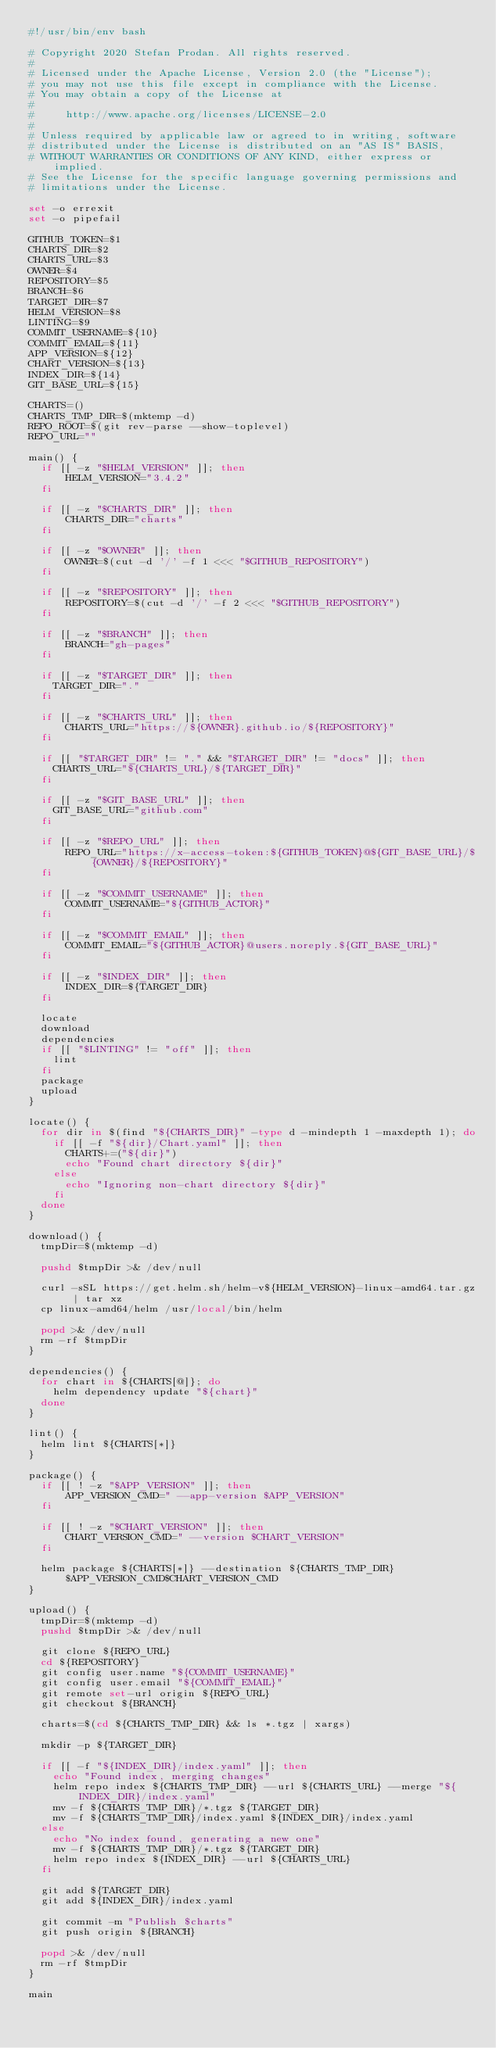<code> <loc_0><loc_0><loc_500><loc_500><_Bash_>#!/usr/bin/env bash

# Copyright 2020 Stefan Prodan. All rights reserved.
#
# Licensed under the Apache License, Version 2.0 (the "License");
# you may not use this file except in compliance with the License.
# You may obtain a copy of the License at
#
#     http://www.apache.org/licenses/LICENSE-2.0
#
# Unless required by applicable law or agreed to in writing, software
# distributed under the License is distributed on an "AS IS" BASIS,
# WITHOUT WARRANTIES OR CONDITIONS OF ANY KIND, either express or implied.
# See the License for the specific language governing permissions and
# limitations under the License.

set -o errexit
set -o pipefail

GITHUB_TOKEN=$1
CHARTS_DIR=$2
CHARTS_URL=$3
OWNER=$4
REPOSITORY=$5
BRANCH=$6
TARGET_DIR=$7
HELM_VERSION=$8
LINTING=$9
COMMIT_USERNAME=${10}
COMMIT_EMAIL=${11}
APP_VERSION=${12}
CHART_VERSION=${13}
INDEX_DIR=${14}
GIT_BASE_URL=${15}

CHARTS=()
CHARTS_TMP_DIR=$(mktemp -d)
REPO_ROOT=$(git rev-parse --show-toplevel)
REPO_URL=""

main() {
  if [[ -z "$HELM_VERSION" ]]; then
      HELM_VERSION="3.4.2"
  fi

  if [[ -z "$CHARTS_DIR" ]]; then
      CHARTS_DIR="charts"
  fi

  if [[ -z "$OWNER" ]]; then
      OWNER=$(cut -d '/' -f 1 <<< "$GITHUB_REPOSITORY")
  fi

  if [[ -z "$REPOSITORY" ]]; then
      REPOSITORY=$(cut -d '/' -f 2 <<< "$GITHUB_REPOSITORY")
  fi

  if [[ -z "$BRANCH" ]]; then
      BRANCH="gh-pages"
  fi

  if [[ -z "$TARGET_DIR" ]]; then
    TARGET_DIR="."
  fi

  if [[ -z "$CHARTS_URL" ]]; then
      CHARTS_URL="https://${OWNER}.github.io/${REPOSITORY}"
  fi

  if [[ "$TARGET_DIR" != "." && "$TARGET_DIR" != "docs" ]]; then
    CHARTS_URL="${CHARTS_URL}/${TARGET_DIR}"
  fi

  if [[ -z "$GIT_BASE_URL" ]]; then
    GIT_BASE_URL="github.com"
  fi

  if [[ -z "$REPO_URL" ]]; then
      REPO_URL="https://x-access-token:${GITHUB_TOKEN}@${GIT_BASE_URL}/${OWNER}/${REPOSITORY}"
  fi

  if [[ -z "$COMMIT_USERNAME" ]]; then
      COMMIT_USERNAME="${GITHUB_ACTOR}"
  fi

  if [[ -z "$COMMIT_EMAIL" ]]; then
      COMMIT_EMAIL="${GITHUB_ACTOR}@users.noreply.${GIT_BASE_URL}"
  fi

  if [[ -z "$INDEX_DIR" ]]; then
      INDEX_DIR=${TARGET_DIR}
  fi

  locate
  download
  dependencies
  if [[ "$LINTING" != "off" ]]; then
    lint
  fi
  package
  upload
}

locate() {
  for dir in $(find "${CHARTS_DIR}" -type d -mindepth 1 -maxdepth 1); do
    if [[ -f "${dir}/Chart.yaml" ]]; then
      CHARTS+=("${dir}")
      echo "Found chart directory ${dir}"
    else
      echo "Ignoring non-chart directory ${dir}"
    fi
  done
}

download() {
  tmpDir=$(mktemp -d)

  pushd $tmpDir >& /dev/null

  curl -sSL https://get.helm.sh/helm-v${HELM_VERSION}-linux-amd64.tar.gz | tar xz
  cp linux-amd64/helm /usr/local/bin/helm

  popd >& /dev/null
  rm -rf $tmpDir
}

dependencies() {
  for chart in ${CHARTS[@]}; do
    helm dependency update "${chart}"
  done
}

lint() {
  helm lint ${CHARTS[*]}
}

package() {
  if [[ ! -z "$APP_VERSION" ]]; then
      APP_VERSION_CMD=" --app-version $APP_VERSION"
  fi

  if [[ ! -z "$CHART_VERSION" ]]; then
      CHART_VERSION_CMD=" --version $CHART_VERSION"
  fi

  helm package ${CHARTS[*]} --destination ${CHARTS_TMP_DIR} $APP_VERSION_CMD$CHART_VERSION_CMD
}

upload() {
  tmpDir=$(mktemp -d)
  pushd $tmpDir >& /dev/null

  git clone ${REPO_URL}
  cd ${REPOSITORY}
  git config user.name "${COMMIT_USERNAME}"
  git config user.email "${COMMIT_EMAIL}"
  git remote set-url origin ${REPO_URL}
  git checkout ${BRANCH}

  charts=$(cd ${CHARTS_TMP_DIR} && ls *.tgz | xargs)

  mkdir -p ${TARGET_DIR}

  if [[ -f "${INDEX_DIR}/index.yaml" ]]; then
    echo "Found index, merging changes"
    helm repo index ${CHARTS_TMP_DIR} --url ${CHARTS_URL} --merge "${INDEX_DIR}/index.yaml"
    mv -f ${CHARTS_TMP_DIR}/*.tgz ${TARGET_DIR}
    mv -f ${CHARTS_TMP_DIR}/index.yaml ${INDEX_DIR}/index.yaml
  else
    echo "No index found, generating a new one"
    mv -f ${CHARTS_TMP_DIR}/*.tgz ${TARGET_DIR}
    helm repo index ${INDEX_DIR} --url ${CHARTS_URL}
  fi

  git add ${TARGET_DIR}
  git add ${INDEX_DIR}/index.yaml

  git commit -m "Publish $charts"
  git push origin ${BRANCH}

  popd >& /dev/null
  rm -rf $tmpDir
}

main
</code> 